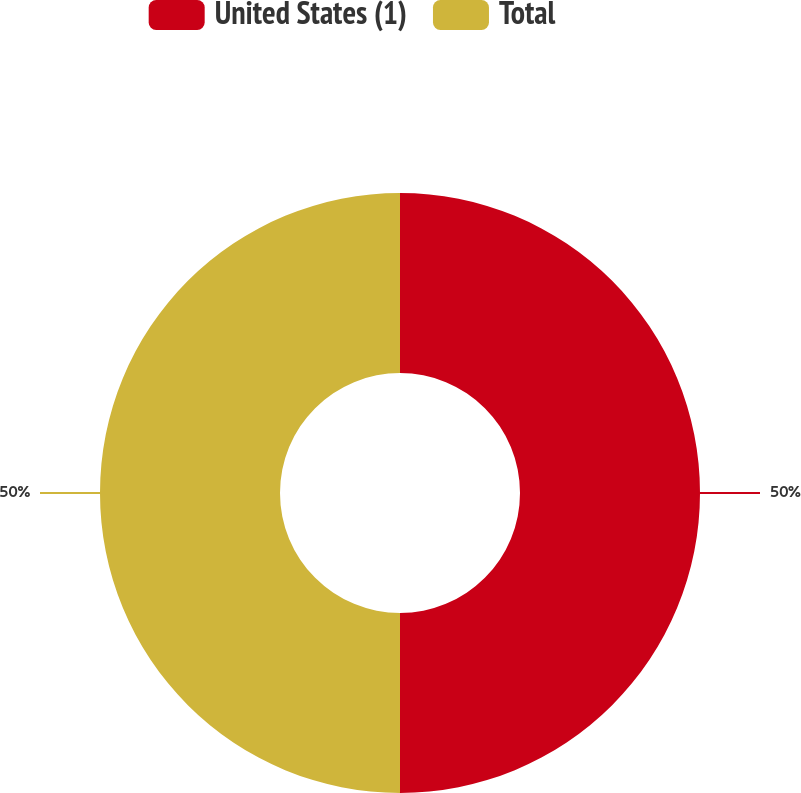<chart> <loc_0><loc_0><loc_500><loc_500><pie_chart><fcel>United States (1)<fcel>Total<nl><fcel>50.0%<fcel>50.0%<nl></chart> 